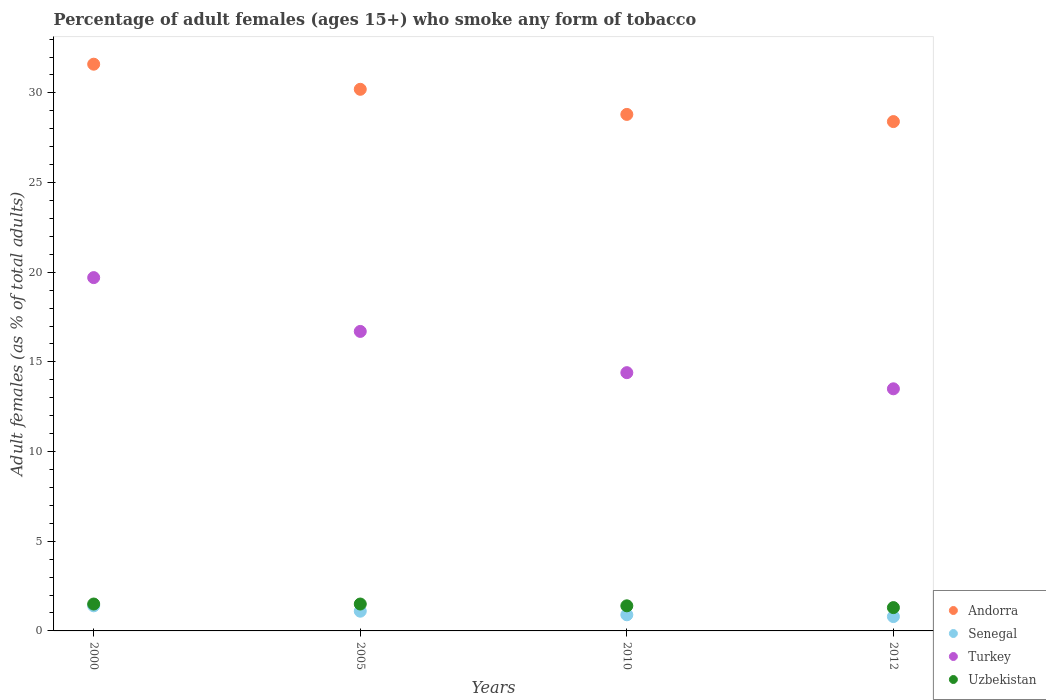How many different coloured dotlines are there?
Keep it short and to the point. 4. Is the number of dotlines equal to the number of legend labels?
Ensure brevity in your answer.  Yes. Across all years, what is the maximum percentage of adult females who smoke in Andorra?
Keep it short and to the point. 31.6. In which year was the percentage of adult females who smoke in Uzbekistan minimum?
Offer a terse response. 2012. What is the difference between the percentage of adult females who smoke in Senegal in 2005 and that in 2012?
Provide a succinct answer. 0.3. What is the difference between the percentage of adult females who smoke in Uzbekistan in 2000 and the percentage of adult females who smoke in Turkey in 2005?
Offer a very short reply. -15.2. What is the average percentage of adult females who smoke in Uzbekistan per year?
Offer a very short reply. 1.43. In the year 2005, what is the difference between the percentage of adult females who smoke in Senegal and percentage of adult females who smoke in Turkey?
Provide a short and direct response. -15.6. What is the ratio of the percentage of adult females who smoke in Turkey in 2010 to that in 2012?
Keep it short and to the point. 1.07. Is the difference between the percentage of adult females who smoke in Senegal in 2005 and 2012 greater than the difference between the percentage of adult females who smoke in Turkey in 2005 and 2012?
Keep it short and to the point. No. What is the difference between the highest and the second highest percentage of adult females who smoke in Senegal?
Offer a very short reply. 0.3. What is the difference between the highest and the lowest percentage of adult females who smoke in Turkey?
Ensure brevity in your answer.  6.2. In how many years, is the percentage of adult females who smoke in Senegal greater than the average percentage of adult females who smoke in Senegal taken over all years?
Your answer should be very brief. 2. Is the sum of the percentage of adult females who smoke in Turkey in 2000 and 2005 greater than the maximum percentage of adult females who smoke in Andorra across all years?
Provide a succinct answer. Yes. Is it the case that in every year, the sum of the percentage of adult females who smoke in Turkey and percentage of adult females who smoke in Andorra  is greater than the percentage of adult females who smoke in Senegal?
Offer a very short reply. Yes. Are the values on the major ticks of Y-axis written in scientific E-notation?
Make the answer very short. No. Does the graph contain grids?
Your response must be concise. No. What is the title of the graph?
Offer a terse response. Percentage of adult females (ages 15+) who smoke any form of tobacco. What is the label or title of the X-axis?
Provide a short and direct response. Years. What is the label or title of the Y-axis?
Your response must be concise. Adult females (as % of total adults). What is the Adult females (as % of total adults) in Andorra in 2000?
Ensure brevity in your answer.  31.6. What is the Adult females (as % of total adults) of Turkey in 2000?
Offer a very short reply. 19.7. What is the Adult females (as % of total adults) of Uzbekistan in 2000?
Provide a short and direct response. 1.5. What is the Adult females (as % of total adults) in Andorra in 2005?
Give a very brief answer. 30.2. What is the Adult females (as % of total adults) of Turkey in 2005?
Ensure brevity in your answer.  16.7. What is the Adult females (as % of total adults) of Uzbekistan in 2005?
Offer a terse response. 1.5. What is the Adult females (as % of total adults) in Andorra in 2010?
Provide a short and direct response. 28.8. What is the Adult females (as % of total adults) in Senegal in 2010?
Offer a very short reply. 0.9. What is the Adult females (as % of total adults) in Turkey in 2010?
Offer a very short reply. 14.4. What is the Adult females (as % of total adults) of Andorra in 2012?
Give a very brief answer. 28.4. What is the Adult females (as % of total adults) of Senegal in 2012?
Your answer should be compact. 0.8. Across all years, what is the maximum Adult females (as % of total adults) of Andorra?
Ensure brevity in your answer.  31.6. Across all years, what is the maximum Adult females (as % of total adults) in Senegal?
Provide a succinct answer. 1.4. Across all years, what is the maximum Adult females (as % of total adults) in Turkey?
Provide a short and direct response. 19.7. Across all years, what is the minimum Adult females (as % of total adults) in Andorra?
Keep it short and to the point. 28.4. Across all years, what is the minimum Adult females (as % of total adults) of Senegal?
Give a very brief answer. 0.8. Across all years, what is the minimum Adult females (as % of total adults) of Uzbekistan?
Offer a terse response. 1.3. What is the total Adult females (as % of total adults) of Andorra in the graph?
Your answer should be compact. 119. What is the total Adult females (as % of total adults) of Senegal in the graph?
Provide a succinct answer. 4.2. What is the total Adult females (as % of total adults) of Turkey in the graph?
Your answer should be very brief. 64.3. What is the difference between the Adult females (as % of total adults) in Senegal in 2000 and that in 2005?
Your answer should be very brief. 0.3. What is the difference between the Adult females (as % of total adults) of Uzbekistan in 2000 and that in 2005?
Offer a terse response. 0. What is the difference between the Adult females (as % of total adults) in Senegal in 2000 and that in 2010?
Provide a succinct answer. 0.5. What is the difference between the Adult females (as % of total adults) in Turkey in 2000 and that in 2012?
Ensure brevity in your answer.  6.2. What is the difference between the Adult females (as % of total adults) in Uzbekistan in 2000 and that in 2012?
Keep it short and to the point. 0.2. What is the difference between the Adult females (as % of total adults) in Senegal in 2005 and that in 2010?
Keep it short and to the point. 0.2. What is the difference between the Adult females (as % of total adults) in Uzbekistan in 2005 and that in 2010?
Your answer should be very brief. 0.1. What is the difference between the Adult females (as % of total adults) of Senegal in 2005 and that in 2012?
Make the answer very short. 0.3. What is the difference between the Adult females (as % of total adults) of Turkey in 2005 and that in 2012?
Your answer should be compact. 3.2. What is the difference between the Adult females (as % of total adults) in Turkey in 2010 and that in 2012?
Your answer should be compact. 0.9. What is the difference between the Adult females (as % of total adults) of Andorra in 2000 and the Adult females (as % of total adults) of Senegal in 2005?
Provide a short and direct response. 30.5. What is the difference between the Adult females (as % of total adults) of Andorra in 2000 and the Adult females (as % of total adults) of Uzbekistan in 2005?
Offer a very short reply. 30.1. What is the difference between the Adult females (as % of total adults) of Senegal in 2000 and the Adult females (as % of total adults) of Turkey in 2005?
Ensure brevity in your answer.  -15.3. What is the difference between the Adult females (as % of total adults) in Senegal in 2000 and the Adult females (as % of total adults) in Uzbekistan in 2005?
Give a very brief answer. -0.1. What is the difference between the Adult females (as % of total adults) in Andorra in 2000 and the Adult females (as % of total adults) in Senegal in 2010?
Provide a short and direct response. 30.7. What is the difference between the Adult females (as % of total adults) of Andorra in 2000 and the Adult females (as % of total adults) of Uzbekistan in 2010?
Make the answer very short. 30.2. What is the difference between the Adult females (as % of total adults) in Senegal in 2000 and the Adult females (as % of total adults) in Turkey in 2010?
Provide a short and direct response. -13. What is the difference between the Adult females (as % of total adults) in Senegal in 2000 and the Adult females (as % of total adults) in Uzbekistan in 2010?
Ensure brevity in your answer.  0. What is the difference between the Adult females (as % of total adults) in Turkey in 2000 and the Adult females (as % of total adults) in Uzbekistan in 2010?
Give a very brief answer. 18.3. What is the difference between the Adult females (as % of total adults) of Andorra in 2000 and the Adult females (as % of total adults) of Senegal in 2012?
Make the answer very short. 30.8. What is the difference between the Adult females (as % of total adults) in Andorra in 2000 and the Adult females (as % of total adults) in Turkey in 2012?
Provide a short and direct response. 18.1. What is the difference between the Adult females (as % of total adults) of Andorra in 2000 and the Adult females (as % of total adults) of Uzbekistan in 2012?
Give a very brief answer. 30.3. What is the difference between the Adult females (as % of total adults) in Turkey in 2000 and the Adult females (as % of total adults) in Uzbekistan in 2012?
Offer a terse response. 18.4. What is the difference between the Adult females (as % of total adults) in Andorra in 2005 and the Adult females (as % of total adults) in Senegal in 2010?
Provide a succinct answer. 29.3. What is the difference between the Adult females (as % of total adults) in Andorra in 2005 and the Adult females (as % of total adults) in Uzbekistan in 2010?
Offer a terse response. 28.8. What is the difference between the Adult females (as % of total adults) in Andorra in 2005 and the Adult females (as % of total adults) in Senegal in 2012?
Your answer should be very brief. 29.4. What is the difference between the Adult females (as % of total adults) in Andorra in 2005 and the Adult females (as % of total adults) in Uzbekistan in 2012?
Offer a terse response. 28.9. What is the difference between the Adult females (as % of total adults) in Senegal in 2005 and the Adult females (as % of total adults) in Turkey in 2012?
Provide a succinct answer. -12.4. What is the difference between the Adult females (as % of total adults) in Senegal in 2005 and the Adult females (as % of total adults) in Uzbekistan in 2012?
Your answer should be very brief. -0.2. What is the difference between the Adult females (as % of total adults) of Turkey in 2005 and the Adult females (as % of total adults) of Uzbekistan in 2012?
Ensure brevity in your answer.  15.4. What is the difference between the Adult females (as % of total adults) of Andorra in 2010 and the Adult females (as % of total adults) of Uzbekistan in 2012?
Provide a succinct answer. 27.5. What is the difference between the Adult females (as % of total adults) in Turkey in 2010 and the Adult females (as % of total adults) in Uzbekistan in 2012?
Give a very brief answer. 13.1. What is the average Adult females (as % of total adults) of Andorra per year?
Make the answer very short. 29.75. What is the average Adult females (as % of total adults) in Senegal per year?
Keep it short and to the point. 1.05. What is the average Adult females (as % of total adults) of Turkey per year?
Provide a succinct answer. 16.07. What is the average Adult females (as % of total adults) of Uzbekistan per year?
Ensure brevity in your answer.  1.43. In the year 2000, what is the difference between the Adult females (as % of total adults) in Andorra and Adult females (as % of total adults) in Senegal?
Give a very brief answer. 30.2. In the year 2000, what is the difference between the Adult females (as % of total adults) of Andorra and Adult females (as % of total adults) of Uzbekistan?
Your response must be concise. 30.1. In the year 2000, what is the difference between the Adult females (as % of total adults) in Senegal and Adult females (as % of total adults) in Turkey?
Give a very brief answer. -18.3. In the year 2005, what is the difference between the Adult females (as % of total adults) of Andorra and Adult females (as % of total adults) of Senegal?
Your response must be concise. 29.1. In the year 2005, what is the difference between the Adult females (as % of total adults) of Andorra and Adult females (as % of total adults) of Uzbekistan?
Provide a succinct answer. 28.7. In the year 2005, what is the difference between the Adult females (as % of total adults) in Senegal and Adult females (as % of total adults) in Turkey?
Your answer should be compact. -15.6. In the year 2005, what is the difference between the Adult females (as % of total adults) in Senegal and Adult females (as % of total adults) in Uzbekistan?
Make the answer very short. -0.4. In the year 2010, what is the difference between the Adult females (as % of total adults) in Andorra and Adult females (as % of total adults) in Senegal?
Give a very brief answer. 27.9. In the year 2010, what is the difference between the Adult females (as % of total adults) in Andorra and Adult females (as % of total adults) in Turkey?
Provide a short and direct response. 14.4. In the year 2010, what is the difference between the Adult females (as % of total adults) of Andorra and Adult females (as % of total adults) of Uzbekistan?
Provide a succinct answer. 27.4. In the year 2010, what is the difference between the Adult females (as % of total adults) of Senegal and Adult females (as % of total adults) of Turkey?
Give a very brief answer. -13.5. In the year 2010, what is the difference between the Adult females (as % of total adults) of Turkey and Adult females (as % of total adults) of Uzbekistan?
Offer a very short reply. 13. In the year 2012, what is the difference between the Adult females (as % of total adults) in Andorra and Adult females (as % of total adults) in Senegal?
Give a very brief answer. 27.6. In the year 2012, what is the difference between the Adult females (as % of total adults) in Andorra and Adult females (as % of total adults) in Uzbekistan?
Provide a short and direct response. 27.1. In the year 2012, what is the difference between the Adult females (as % of total adults) in Senegal and Adult females (as % of total adults) in Turkey?
Provide a succinct answer. -12.7. In the year 2012, what is the difference between the Adult females (as % of total adults) in Senegal and Adult females (as % of total adults) in Uzbekistan?
Your response must be concise. -0.5. What is the ratio of the Adult females (as % of total adults) in Andorra in 2000 to that in 2005?
Your response must be concise. 1.05. What is the ratio of the Adult females (as % of total adults) in Senegal in 2000 to that in 2005?
Offer a terse response. 1.27. What is the ratio of the Adult females (as % of total adults) in Turkey in 2000 to that in 2005?
Make the answer very short. 1.18. What is the ratio of the Adult females (as % of total adults) of Uzbekistan in 2000 to that in 2005?
Keep it short and to the point. 1. What is the ratio of the Adult females (as % of total adults) in Andorra in 2000 to that in 2010?
Your answer should be compact. 1.1. What is the ratio of the Adult females (as % of total adults) in Senegal in 2000 to that in 2010?
Give a very brief answer. 1.56. What is the ratio of the Adult females (as % of total adults) of Turkey in 2000 to that in 2010?
Make the answer very short. 1.37. What is the ratio of the Adult females (as % of total adults) in Uzbekistan in 2000 to that in 2010?
Make the answer very short. 1.07. What is the ratio of the Adult females (as % of total adults) in Andorra in 2000 to that in 2012?
Offer a terse response. 1.11. What is the ratio of the Adult females (as % of total adults) in Senegal in 2000 to that in 2012?
Provide a succinct answer. 1.75. What is the ratio of the Adult females (as % of total adults) of Turkey in 2000 to that in 2012?
Your answer should be very brief. 1.46. What is the ratio of the Adult females (as % of total adults) of Uzbekistan in 2000 to that in 2012?
Keep it short and to the point. 1.15. What is the ratio of the Adult females (as % of total adults) in Andorra in 2005 to that in 2010?
Make the answer very short. 1.05. What is the ratio of the Adult females (as % of total adults) in Senegal in 2005 to that in 2010?
Your response must be concise. 1.22. What is the ratio of the Adult females (as % of total adults) of Turkey in 2005 to that in 2010?
Your answer should be compact. 1.16. What is the ratio of the Adult females (as % of total adults) of Uzbekistan in 2005 to that in 2010?
Give a very brief answer. 1.07. What is the ratio of the Adult females (as % of total adults) in Andorra in 2005 to that in 2012?
Provide a succinct answer. 1.06. What is the ratio of the Adult females (as % of total adults) in Senegal in 2005 to that in 2012?
Offer a terse response. 1.38. What is the ratio of the Adult females (as % of total adults) of Turkey in 2005 to that in 2012?
Keep it short and to the point. 1.24. What is the ratio of the Adult females (as % of total adults) of Uzbekistan in 2005 to that in 2012?
Ensure brevity in your answer.  1.15. What is the ratio of the Adult females (as % of total adults) in Andorra in 2010 to that in 2012?
Provide a short and direct response. 1.01. What is the ratio of the Adult females (as % of total adults) of Turkey in 2010 to that in 2012?
Your answer should be compact. 1.07. What is the difference between the highest and the second highest Adult females (as % of total adults) in Turkey?
Offer a very short reply. 3. What is the difference between the highest and the second highest Adult females (as % of total adults) of Uzbekistan?
Make the answer very short. 0. What is the difference between the highest and the lowest Adult females (as % of total adults) in Andorra?
Your answer should be compact. 3.2. What is the difference between the highest and the lowest Adult females (as % of total adults) in Turkey?
Provide a succinct answer. 6.2. 